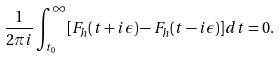Convert formula to latex. <formula><loc_0><loc_0><loc_500><loc_500>\frac { 1 } { 2 \pi i } \int _ { t _ { 0 } } ^ { \infty } [ F _ { h } ( t + i \epsilon ) - F _ { h } ( t - i \epsilon ) ] d t = 0 .</formula> 